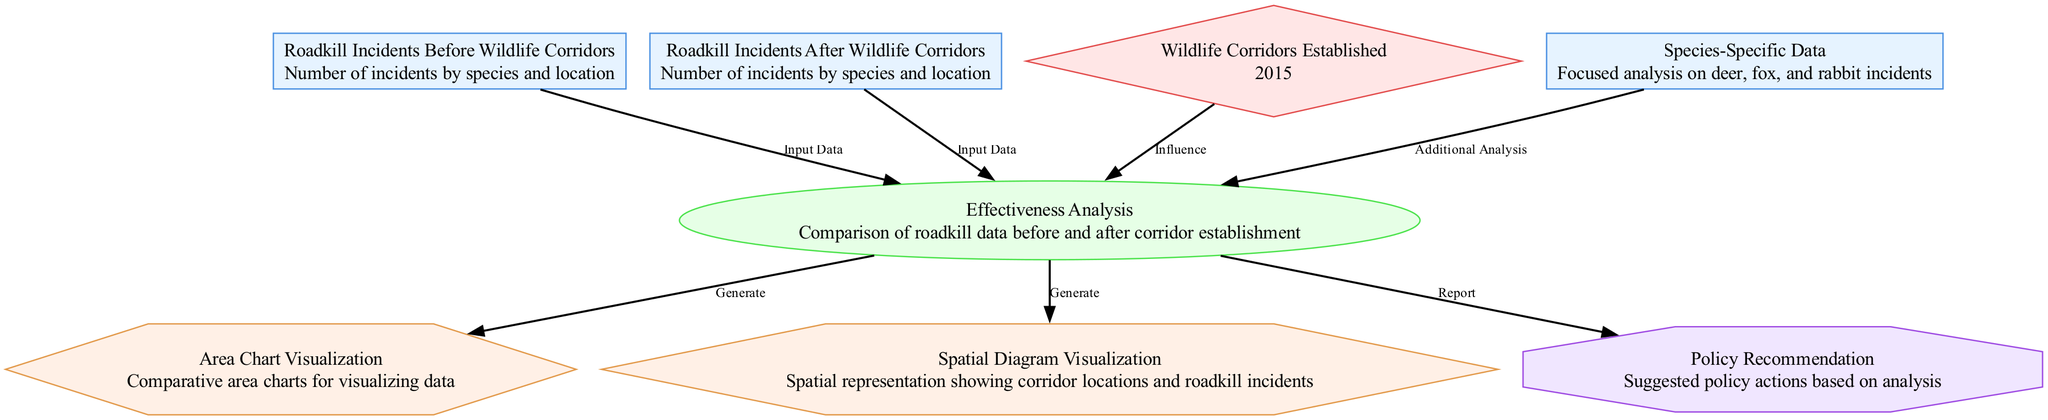What is the year when wildlife corridors were established? The diagram specifies that wildlife corridors were established in 2015, indicated in the node labeled "Wildlife Corridors Established."
Answer: 2015 How many distinct types of data are presented in the diagram? By examining the nodes in the diagram, we see that there are two data nodes: "Roadkill Incidents Before Wildlife Corridors" and "Roadkill Incidents After Wildlife Corridors."
Answer: 2 What type of analysis is conducted in the diagram? The node labeled "Effectiveness Analysis" indicates that the analysis conducted is a comparison of roadkill data before and after the establishment of wildlife corridors.
Answer: Comparison What type of visualizations are generated from the analysis? According to the edges stemming from the "Effectiveness Analysis" node, two types of visualizations are generated: an area chart and a spatial diagram.
Answer: Area chart and spatial diagram Which species are specifically analyzed for roadkill incidents? The node "Species-Specific Data" refers explicitly to a focused analysis on deer, fox, and rabbit incidents, indicating these species are the subjects of the analysis.
Answer: Deer, fox, rabbit What influence does the establishment of wildlife corridors have according to the diagram? The establishment of wildlife corridors influences the "Effectiveness Analysis," which incorporates pertinent data before and after the corridors' creation to evaluate the impact on roadkill incidents.
Answer: Effectiveness analysis What is the outcome suggested after the analysis is completed? The "Policy Recommendation" node indicates that the outcome of the analysis will include suggested policy actions based on the findings from the evaluation of roadkill incidents.
Answer: Suggested policy actions 